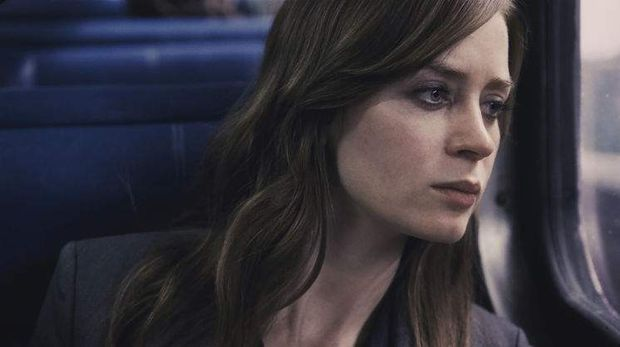What might be on her mind in this scene? In this scene, she could be pondering over the complexities of her life, dealing with the emotional turmoil or reflecting on past incidents that have significant consequences. The window serves not only as a physical barrier but perhaps as a metaphor for the emotional distance she feels from her own happiness or peace. 